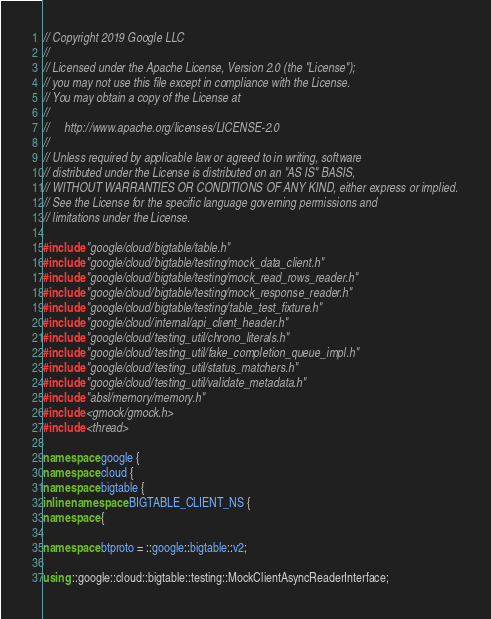Convert code to text. <code><loc_0><loc_0><loc_500><loc_500><_C++_>// Copyright 2019 Google LLC
//
// Licensed under the Apache License, Version 2.0 (the "License");
// you may not use this file except in compliance with the License.
// You may obtain a copy of the License at
//
//     http://www.apache.org/licenses/LICENSE-2.0
//
// Unless required by applicable law or agreed to in writing, software
// distributed under the License is distributed on an "AS IS" BASIS,
// WITHOUT WARRANTIES OR CONDITIONS OF ANY KIND, either express or implied.
// See the License for the specific language governing permissions and
// limitations under the License.

#include "google/cloud/bigtable/table.h"
#include "google/cloud/bigtable/testing/mock_data_client.h"
#include "google/cloud/bigtable/testing/mock_read_rows_reader.h"
#include "google/cloud/bigtable/testing/mock_response_reader.h"
#include "google/cloud/bigtable/testing/table_test_fixture.h"
#include "google/cloud/internal/api_client_header.h"
#include "google/cloud/testing_util/chrono_literals.h"
#include "google/cloud/testing_util/fake_completion_queue_impl.h"
#include "google/cloud/testing_util/status_matchers.h"
#include "google/cloud/testing_util/validate_metadata.h"
#include "absl/memory/memory.h"
#include <gmock/gmock.h>
#include <thread>

namespace google {
namespace cloud {
namespace bigtable {
inline namespace BIGTABLE_CLIENT_NS {
namespace {

namespace btproto = ::google::bigtable::v2;

using ::google::cloud::bigtable::testing::MockClientAsyncReaderInterface;</code> 